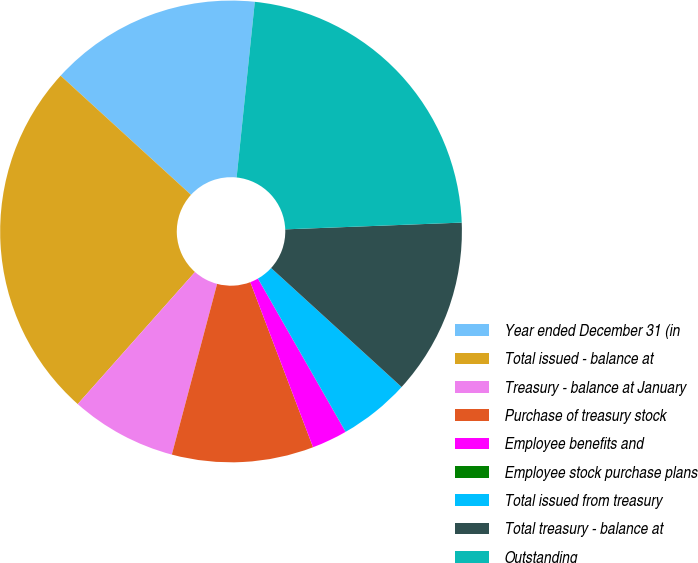Convert chart to OTSL. <chart><loc_0><loc_0><loc_500><loc_500><pie_chart><fcel>Year ended December 31 (in<fcel>Total issued - balance at<fcel>Treasury - balance at January<fcel>Purchase of treasury stock<fcel>Employee benefits and<fcel>Employee stock purchase plans<fcel>Total issued from treasury<fcel>Total treasury - balance at<fcel>Outstanding<nl><fcel>14.86%<fcel>25.23%<fcel>7.43%<fcel>9.91%<fcel>2.48%<fcel>0.01%<fcel>4.96%<fcel>12.38%<fcel>22.75%<nl></chart> 